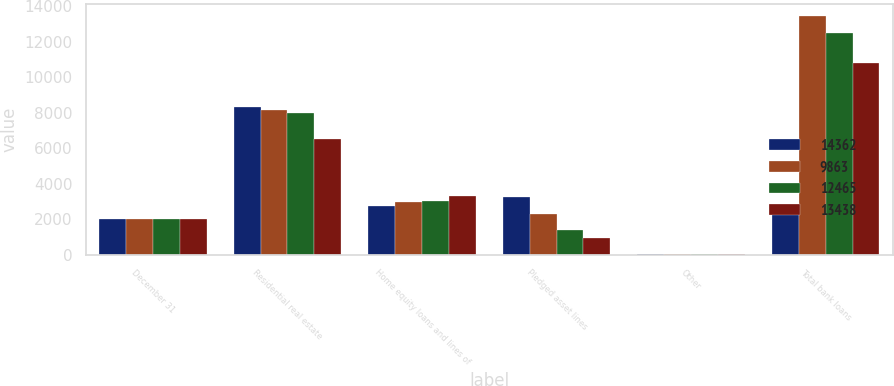Convert chart to OTSL. <chart><loc_0><loc_0><loc_500><loc_500><stacked_bar_chart><ecel><fcel>December 31<fcel>Residential real estate<fcel>Home equity loans and lines of<fcel>Pledged asset lines<fcel>Other<fcel>Total bank loans<nl><fcel>14362<fcel>2015<fcel>8334<fcel>2735<fcel>3232<fcel>61<fcel>2735<nl><fcel>9863<fcel>2014<fcel>8127<fcel>2955<fcel>2320<fcel>36<fcel>13438<nl><fcel>12465<fcel>2013<fcel>8006<fcel>3041<fcel>1384<fcel>34<fcel>12465<nl><fcel>13438<fcel>2012<fcel>6507<fcel>3287<fcel>963<fcel>22<fcel>10779<nl></chart> 